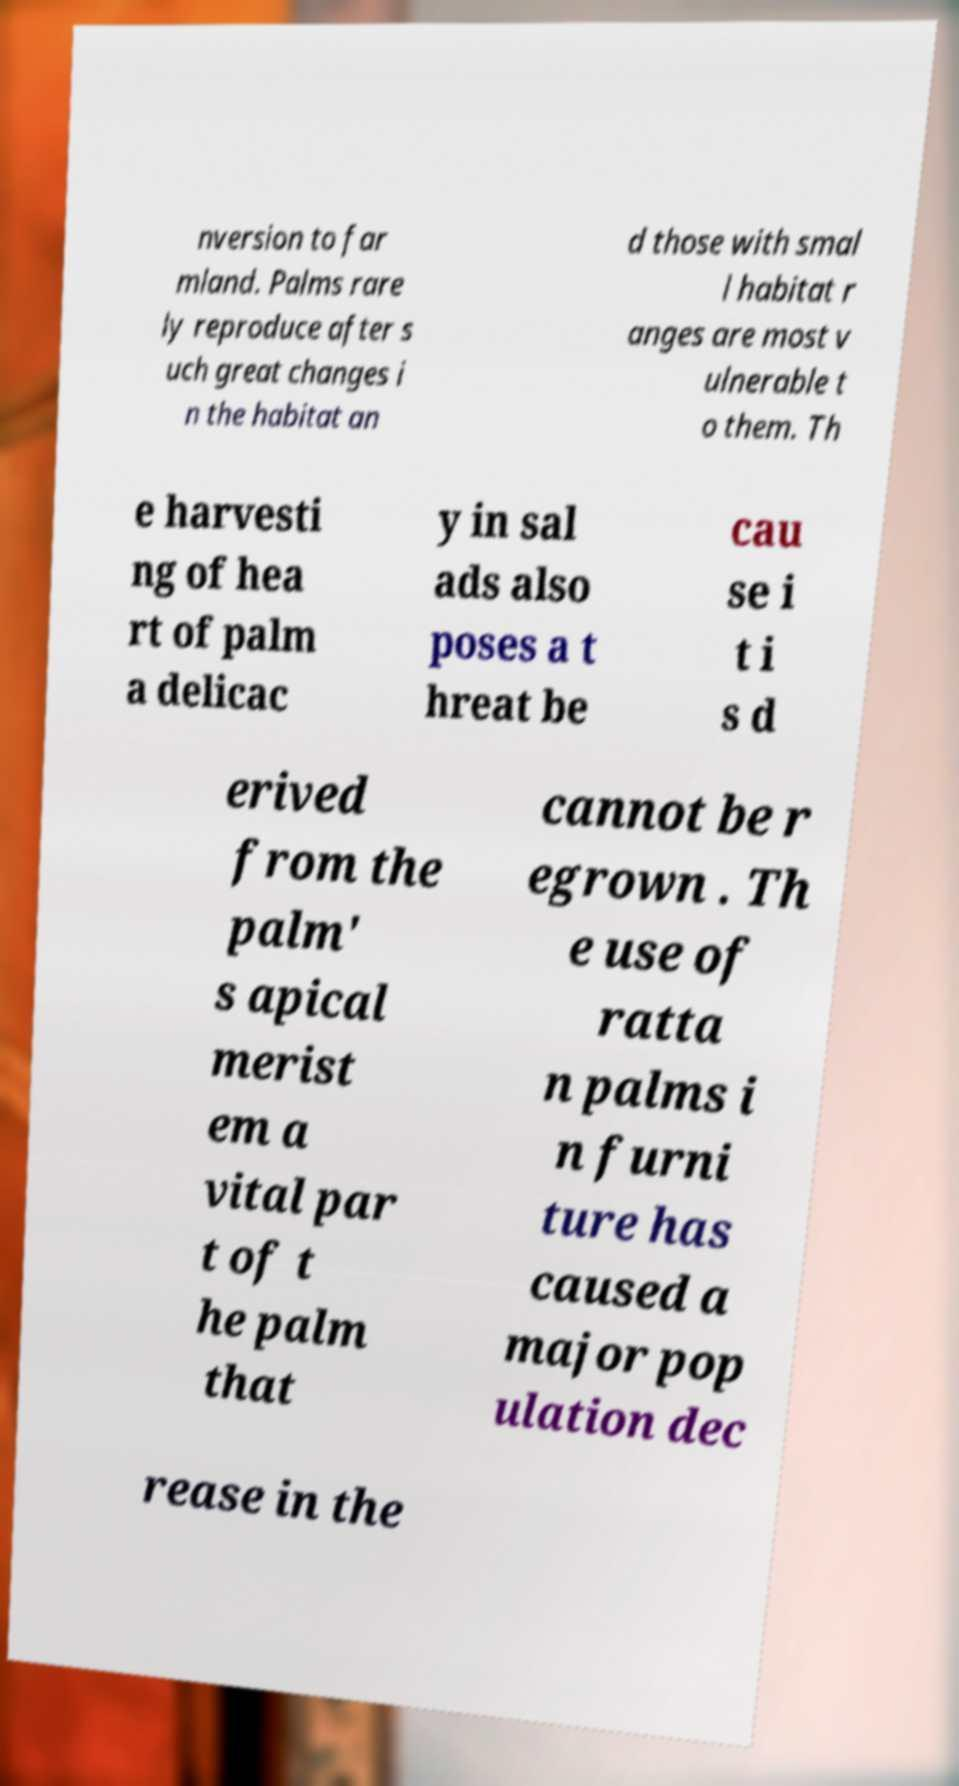Can you accurately transcribe the text from the provided image for me? nversion to far mland. Palms rare ly reproduce after s uch great changes i n the habitat an d those with smal l habitat r anges are most v ulnerable t o them. Th e harvesti ng of hea rt of palm a delicac y in sal ads also poses a t hreat be cau se i t i s d erived from the palm' s apical merist em a vital par t of t he palm that cannot be r egrown . Th e use of ratta n palms i n furni ture has caused a major pop ulation dec rease in the 